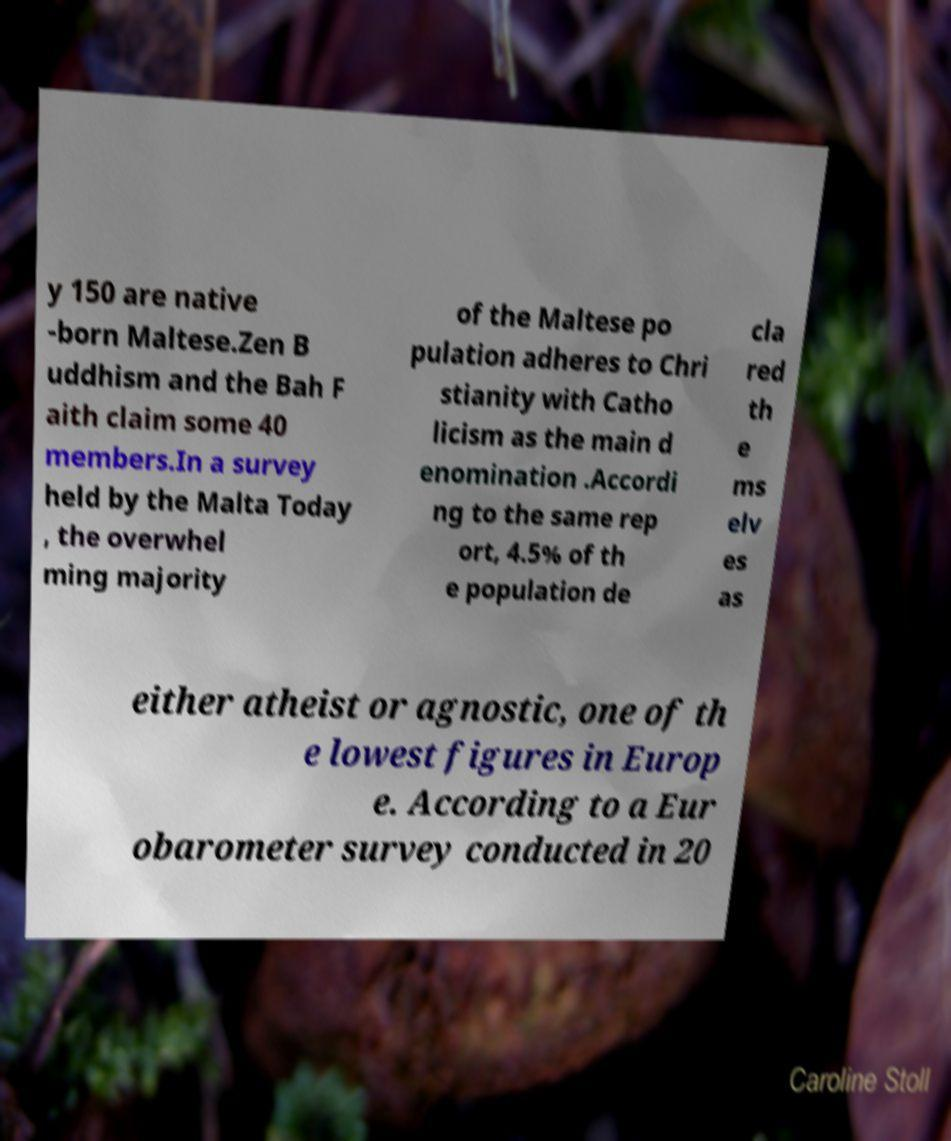What messages or text are displayed in this image? I need them in a readable, typed format. y 150 are native -born Maltese.Zen B uddhism and the Bah F aith claim some 40 members.In a survey held by the Malta Today , the overwhel ming majority of the Maltese po pulation adheres to Chri stianity with Catho licism as the main d enomination .Accordi ng to the same rep ort, 4.5% of th e population de cla red th e ms elv es as either atheist or agnostic, one of th e lowest figures in Europ e. According to a Eur obarometer survey conducted in 20 